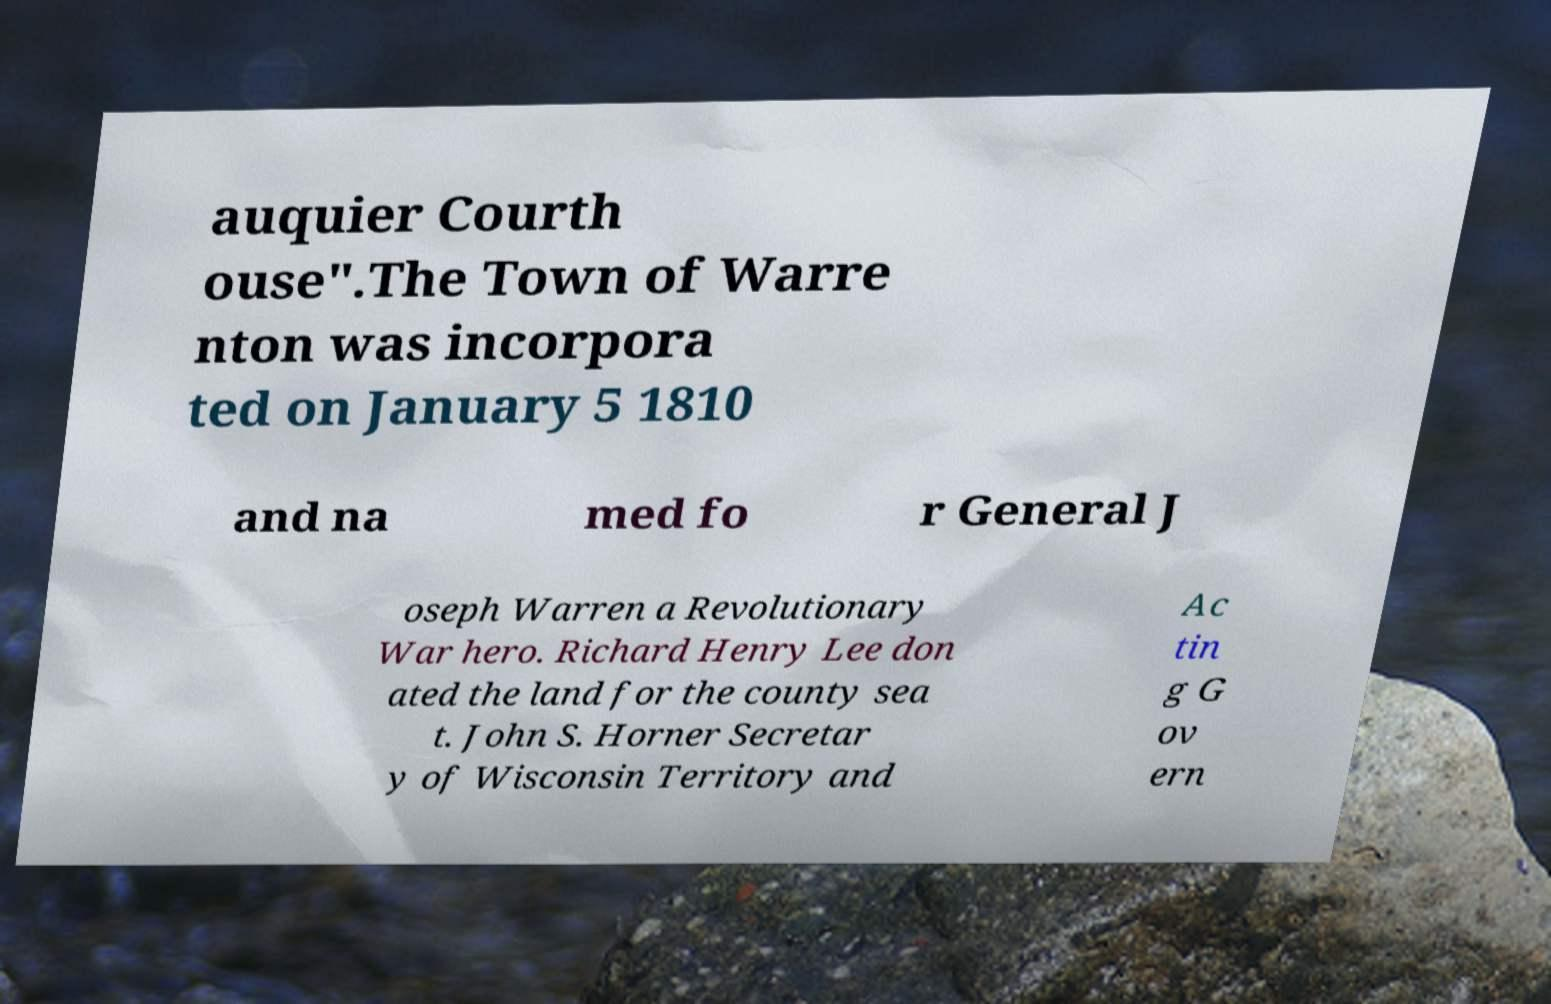What messages or text are displayed in this image? I need them in a readable, typed format. auquier Courth ouse".The Town of Warre nton was incorpora ted on January 5 1810 and na med fo r General J oseph Warren a Revolutionary War hero. Richard Henry Lee don ated the land for the county sea t. John S. Horner Secretar y of Wisconsin Territory and Ac tin g G ov ern 